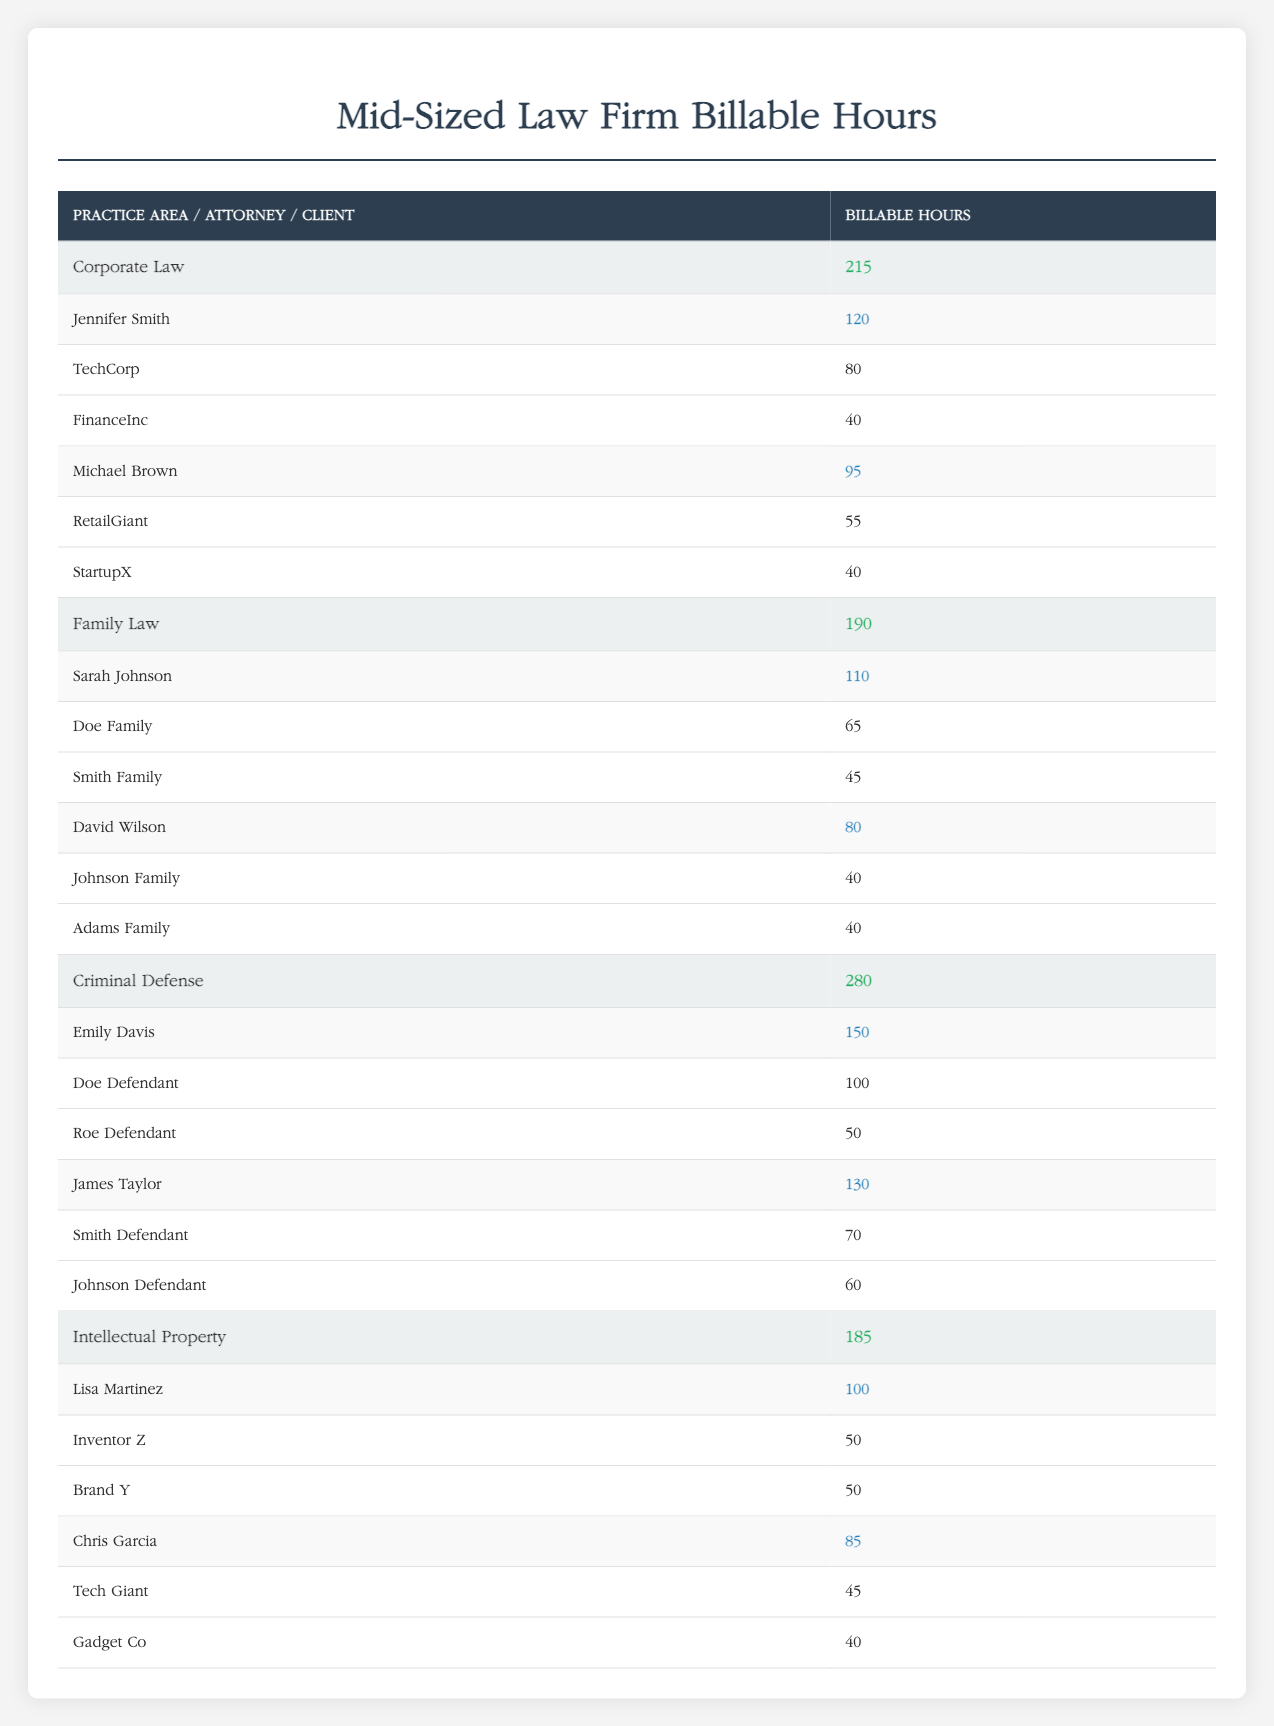What is the total number of billable hours for Corporate Law? The total billable hours for Corporate Law is calculated by adding the hours from both attorneys: Jennifer Smith (120 hours) + Michael Brown (95 hours) = 215 hours.
Answer: 215 hours How many clients does Sarah Johnson have? The table lists two clients for Sarah Johnson: Doe Family and Smith Family. Therefore, she has a total of 2 clients.
Answer: 2 clients Which attorney has the highest number of billable hours? By comparing the billable hours: Emily Davis (150), James Taylor (130), Sarah Johnson (110), etc., it's clear that Emily Davis has the highest with 150 billable hours.
Answer: Emily Davis What is the average billable hours for attorneys in Criminal Defense? To find the average, add the billable hours of the two attorneys: Emily Davis (150) + James Taylor (130) = 280 total hours. Then divide by 2 (the number of attorneys): 280 / 2 = 140.
Answer: 140 Does Chris Garcia have more billable hours than David Wilson? Chris Garcia has 85 billable hours, while David Wilson has 80. Therefore, Chris Garcia has more hours than David Wilson.
Answer: Yes What is the total number of billable hours for all attorneys in Family Law? The total is determined by adding the hours: Sarah Johnson (110) + David Wilson (80) = 190 hours.
Answer: 190 hours How many clients does Michael Brown represent? The clients listed for Michael Brown are RetailGiant and StartupX, totaling 2 clients.
Answer: 2 clients What percentage of the total billable hours in Intellectual Property does Lisa Martinez account for? First, sum the hours for Intellectual Property: Lisa Martinez (100) + Chris Garcia (85) = 185 hours. Lisa's percentage is calculated as (100 / 185) * 100 ≈ 54.05%.
Answer: 54.05% What is the combined billable hours of all attorneys? The total hours can be calculated by summing all the billable hours of each attorney: 120 (Jennifer Smith) + 95 (Michael Brown) + 110 (Sarah Johnson) + 80 (David Wilson) + 150 (Emily Davis) + 130 (James Taylor) + 100 (Lisa Martinez) + 85 (Chris Garcia) = 970 hours.
Answer: 970 hours 